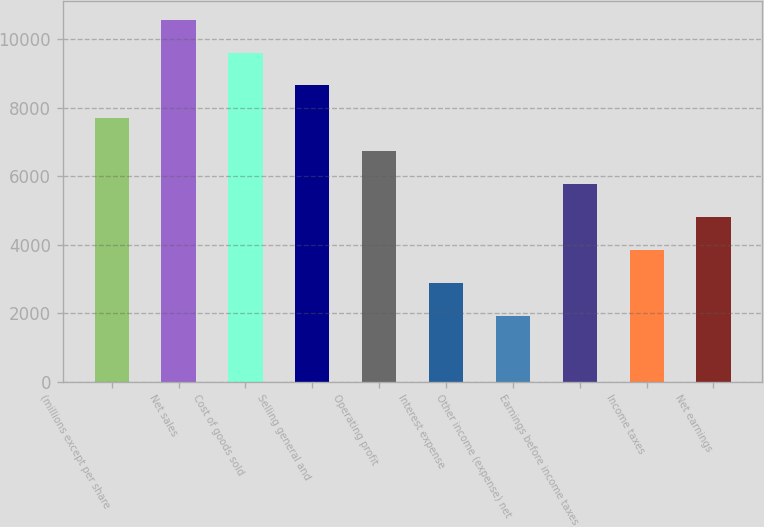<chart> <loc_0><loc_0><loc_500><loc_500><bar_chart><fcel>(millions except per share<fcel>Net sales<fcel>Cost of goods sold<fcel>Selling general and<fcel>Operating profit<fcel>Interest expense<fcel>Other income (expense) net<fcel>Earnings before income taxes<fcel>Income taxes<fcel>Net earnings<nl><fcel>7691.58<fcel>10575.1<fcel>9613.94<fcel>8652.76<fcel>6730.4<fcel>2885.68<fcel>1924.5<fcel>5769.22<fcel>3846.86<fcel>4808.04<nl></chart> 